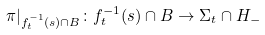Convert formula to latex. <formula><loc_0><loc_0><loc_500><loc_500>\pi | _ { f _ { t } ^ { - 1 } ( s ) \cap B } \colon f _ { t } ^ { - 1 } ( s ) \cap B \to \Sigma _ { t } \cap H _ { - }</formula> 